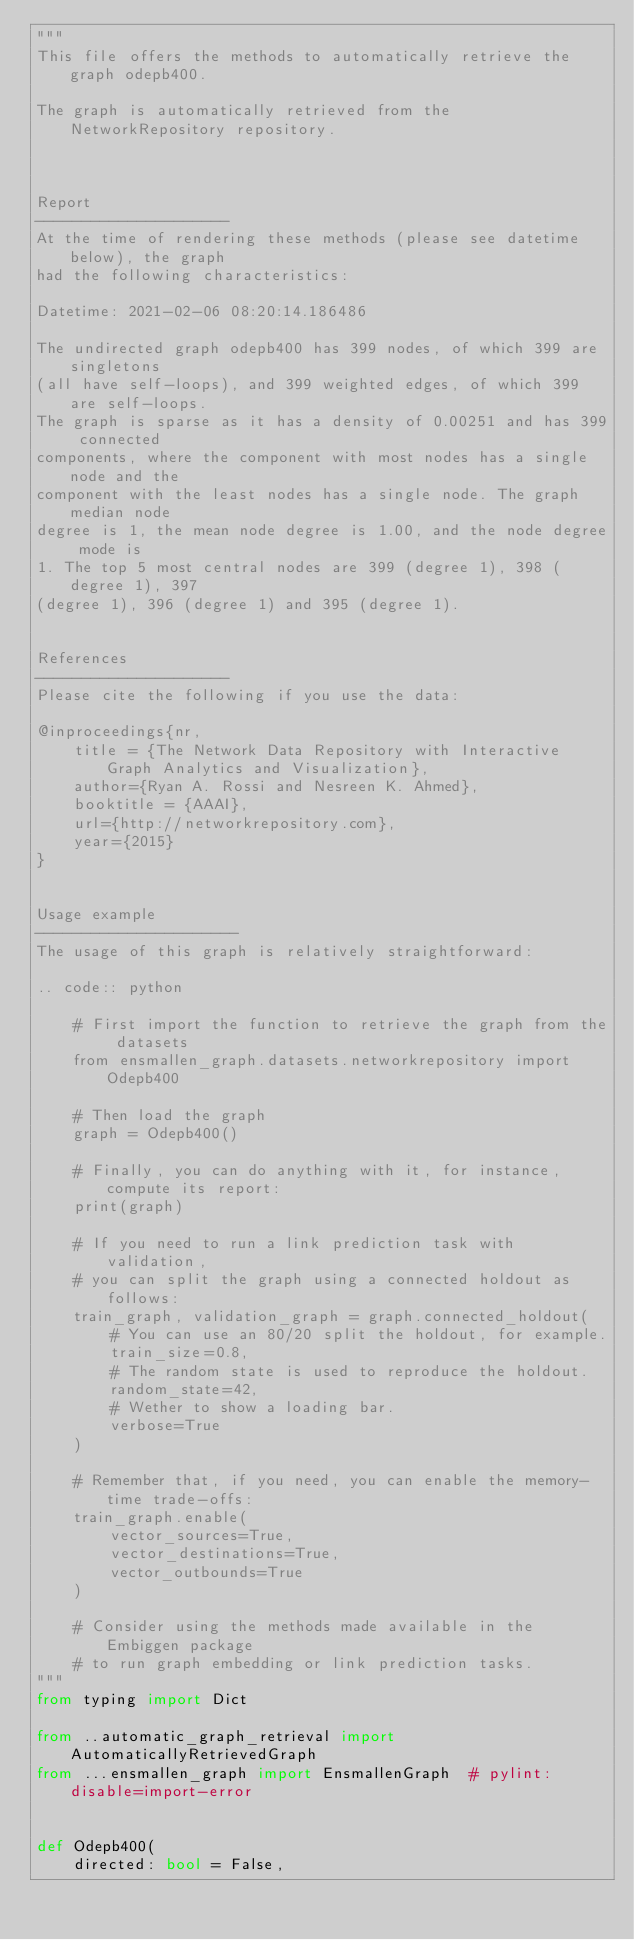<code> <loc_0><loc_0><loc_500><loc_500><_Python_>"""
This file offers the methods to automatically retrieve the graph odepb400.

The graph is automatically retrieved from the NetworkRepository repository. 



Report
---------------------
At the time of rendering these methods (please see datetime below), the graph
had the following characteristics:

Datetime: 2021-02-06 08:20:14.186486

The undirected graph odepb400 has 399 nodes, of which 399 are singletons
(all have self-loops), and 399 weighted edges, of which 399 are self-loops.
The graph is sparse as it has a density of 0.00251 and has 399 connected
components, where the component with most nodes has a single node and the
component with the least nodes has a single node. The graph median node
degree is 1, the mean node degree is 1.00, and the node degree mode is
1. The top 5 most central nodes are 399 (degree 1), 398 (degree 1), 397
(degree 1), 396 (degree 1) and 395 (degree 1).


References
---------------------
Please cite the following if you use the data:

@inproceedings{nr,
    title = {The Network Data Repository with Interactive Graph Analytics and Visualization},
    author={Ryan A. Rossi and Nesreen K. Ahmed},
    booktitle = {AAAI},
    url={http://networkrepository.com},
    year={2015}
}


Usage example
----------------------
The usage of this graph is relatively straightforward:

.. code:: python

    # First import the function to retrieve the graph from the datasets
    from ensmallen_graph.datasets.networkrepository import Odepb400

    # Then load the graph
    graph = Odepb400()

    # Finally, you can do anything with it, for instance, compute its report:
    print(graph)

    # If you need to run a link prediction task with validation,
    # you can split the graph using a connected holdout as follows:
    train_graph, validation_graph = graph.connected_holdout(
        # You can use an 80/20 split the holdout, for example.
        train_size=0.8,
        # The random state is used to reproduce the holdout.
        random_state=42,
        # Wether to show a loading bar.
        verbose=True
    )

    # Remember that, if you need, you can enable the memory-time trade-offs:
    train_graph.enable(
        vector_sources=True,
        vector_destinations=True,
        vector_outbounds=True
    )

    # Consider using the methods made available in the Embiggen package
    # to run graph embedding or link prediction tasks.
"""
from typing import Dict

from ..automatic_graph_retrieval import AutomaticallyRetrievedGraph
from ...ensmallen_graph import EnsmallenGraph  # pylint: disable=import-error


def Odepb400(
    directed: bool = False,</code> 